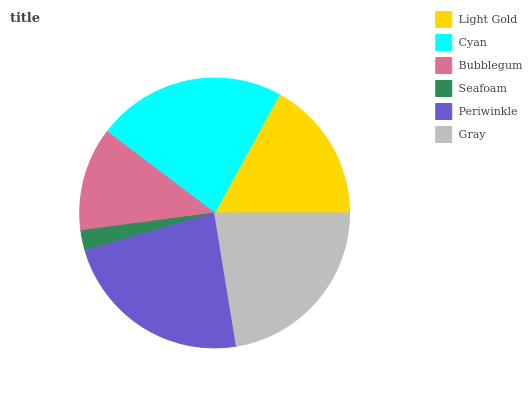Is Seafoam the minimum?
Answer yes or no. Yes. Is Periwinkle the maximum?
Answer yes or no. Yes. Is Cyan the minimum?
Answer yes or no. No. Is Cyan the maximum?
Answer yes or no. No. Is Cyan greater than Light Gold?
Answer yes or no. Yes. Is Light Gold less than Cyan?
Answer yes or no. Yes. Is Light Gold greater than Cyan?
Answer yes or no. No. Is Cyan less than Light Gold?
Answer yes or no. No. Is Gray the high median?
Answer yes or no. Yes. Is Light Gold the low median?
Answer yes or no. Yes. Is Bubblegum the high median?
Answer yes or no. No. Is Gray the low median?
Answer yes or no. No. 